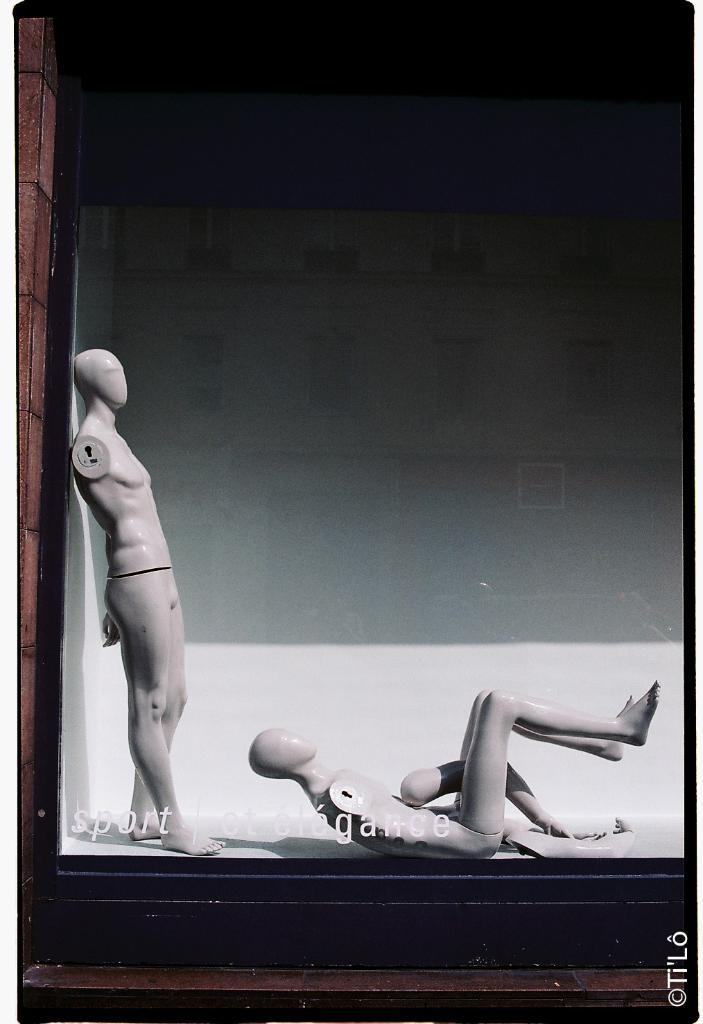What is leaning against the wall on the left side of the image? There is a doll leaning against a wall on the left side of the image. What is laying on the floor in the middle of the image? There is a dog laying on the floor in the middle of the image. Can you describe any additional features of the image? There is a watermark at the bottom of the image. What word is the goose saying in the image? There is no goose present in the image, so it is not possible to determine what word it might be saying. 